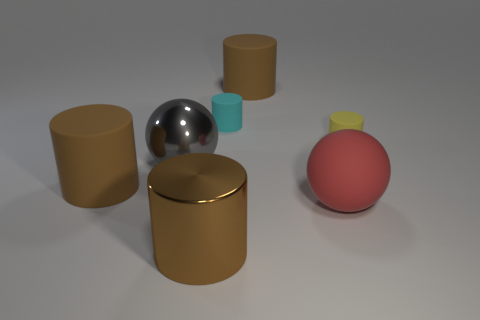Subtract all brown cylinders. How many were subtracted if there are1brown cylinders left? 2 Subtract all small rubber cylinders. How many cylinders are left? 3 Subtract all purple cubes. How many brown cylinders are left? 3 Subtract 4 cylinders. How many cylinders are left? 1 Add 1 large rubber cylinders. How many objects exist? 8 Subtract all cyan cylinders. How many cylinders are left? 4 Subtract all cylinders. How many objects are left? 2 Add 1 small rubber objects. How many small rubber objects are left? 3 Add 1 small green metal objects. How many small green metal objects exist? 1 Subtract 0 green cylinders. How many objects are left? 7 